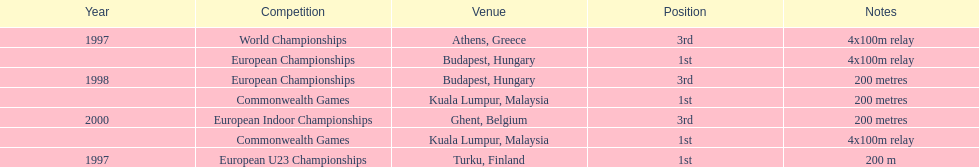How many 4x 100m relay competitions occurred? 3. Could you parse the entire table? {'header': ['Year', 'Competition', 'Venue', 'Position', 'Notes'], 'rows': [['1997', 'World Championships', 'Athens, Greece', '3rd', '4x100m relay'], ['', 'European Championships', 'Budapest, Hungary', '1st', '4x100m relay'], ['1998', 'European Championships', 'Budapest, Hungary', '3rd', '200 metres'], ['', 'Commonwealth Games', 'Kuala Lumpur, Malaysia', '1st', '200 metres'], ['2000', 'European Indoor Championships', 'Ghent, Belgium', '3rd', '200 metres'], ['', 'Commonwealth Games', 'Kuala Lumpur, Malaysia', '1st', '4x100m relay'], ['1997', 'European U23 Championships', 'Turku, Finland', '1st', '200 m']]} 